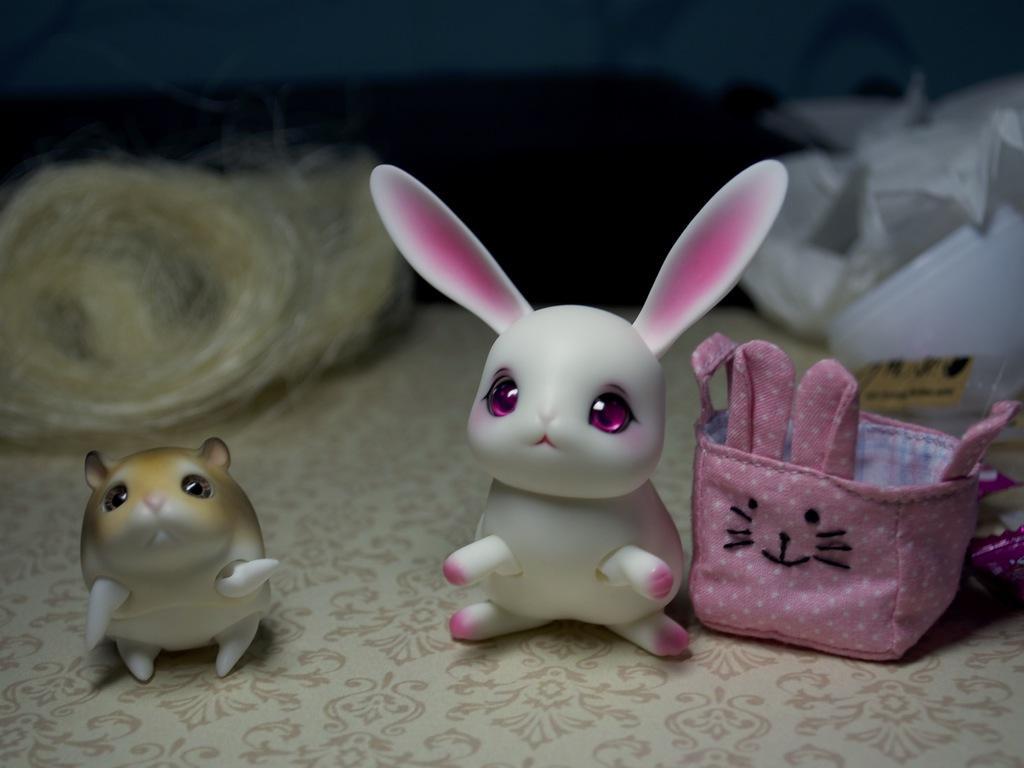Describe this image in one or two sentences. As we can see in the image there is a table. on table there are toys, purse and ropes. 